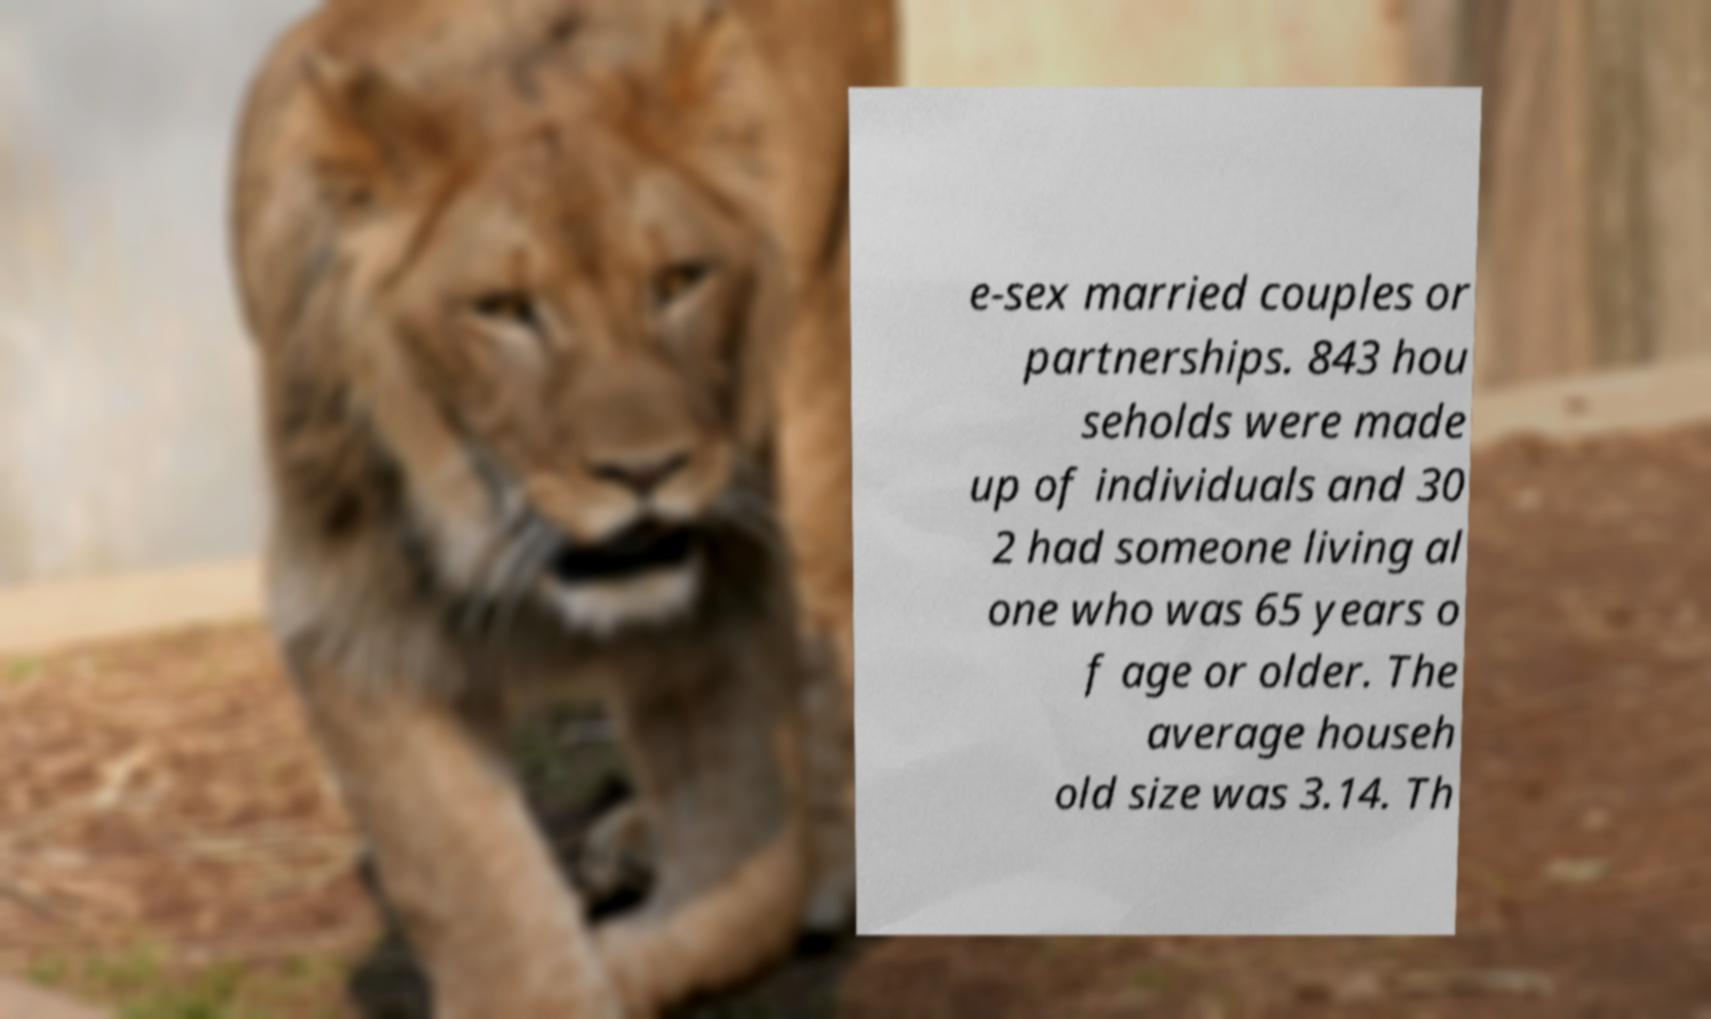Could you extract and type out the text from this image? e-sex married couples or partnerships. 843 hou seholds were made up of individuals and 30 2 had someone living al one who was 65 years o f age or older. The average househ old size was 3.14. Th 